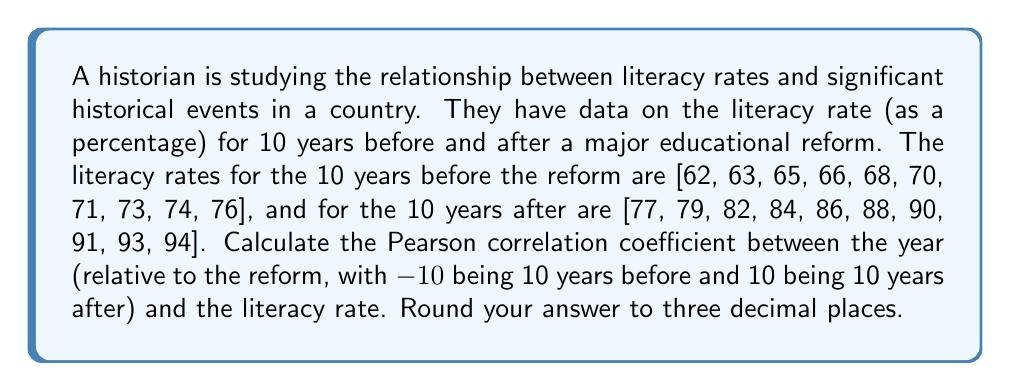Show me your answer to this math problem. To calculate the Pearson correlation coefficient, we'll follow these steps:

1. Let $x$ be the years relative to the reform (-10 to 10, excluding 0) and $y$ be the corresponding literacy rates.

2. Calculate the means:
   $\bar{x} = 0$ (since the years are symmetrical around 0)
   $\bar{y} = \frac{62 + 63 + ... + 93 + 94}{20} = 77.9$

3. Calculate the sums needed for the correlation coefficient:
   $\sum_{i=1}^{20} (x_i - \bar{x})(y_i - \bar{y})$
   $\sum_{i=1}^{20} (x_i - \bar{x})^2$
   $\sum_{i=1}^{20} (y_i - \bar{y})^2$

4. For $\sum_{i=1}^{20} (x_i - \bar{x})(y_i - \bar{y})$:
   $(-10)(62-77.9) + (-9)(63-77.9) + ... + (9)(93-77.9) + (10)(94-77.9)$
   $= 3,190$

5. For $\sum_{i=1}^{20} (x_i - \bar{x})^2$:
   $(-10)^2 + (-9)^2 + ... + 9^2 + 10^2 = 770$

6. For $\sum_{i=1}^{20} (y_i - \bar{y})^2$:
   $(62-77.9)^2 + (63-77.9)^2 + ... + (93-77.9)^2 + (94-77.9)^2$
   $= 2,424.2$

7. Apply the Pearson correlation coefficient formula:
   $$r = \frac{\sum_{i=1}^{20} (x_i - \bar{x})(y_i - \bar{y})}{\sqrt{\sum_{i=1}^{20} (x_i - \bar{x})^2 \sum_{i=1}^{20} (y_i - \bar{y})^2}}$$

   $$r = \frac{3,190}{\sqrt{770 \times 2,424.2}} \approx 0.987$$

8. Round to three decimal places: 0.987
Answer: 0.987 